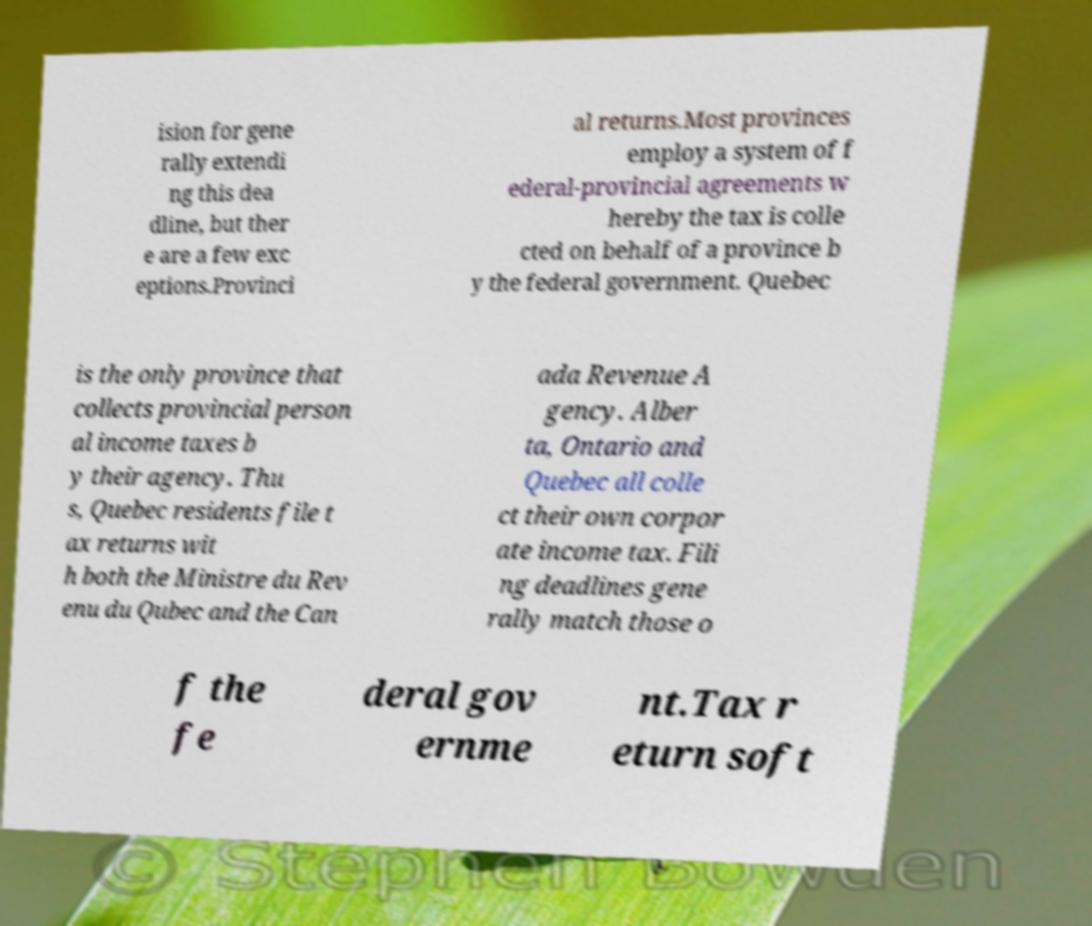I need the written content from this picture converted into text. Can you do that? ision for gene rally extendi ng this dea dline, but ther e are a few exc eptions.Provinci al returns.Most provinces employ a system of f ederal-provincial agreements w hereby the tax is colle cted on behalf of a province b y the federal government. Quebec is the only province that collects provincial person al income taxes b y their agency. Thu s, Quebec residents file t ax returns wit h both the Ministre du Rev enu du Qubec and the Can ada Revenue A gency. Alber ta, Ontario and Quebec all colle ct their own corpor ate income tax. Fili ng deadlines gene rally match those o f the fe deral gov ernme nt.Tax r eturn soft 